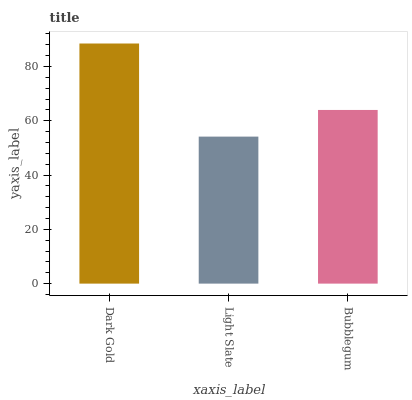Is Light Slate the minimum?
Answer yes or no. Yes. Is Dark Gold the maximum?
Answer yes or no. Yes. Is Bubblegum the minimum?
Answer yes or no. No. Is Bubblegum the maximum?
Answer yes or no. No. Is Bubblegum greater than Light Slate?
Answer yes or no. Yes. Is Light Slate less than Bubblegum?
Answer yes or no. Yes. Is Light Slate greater than Bubblegum?
Answer yes or no. No. Is Bubblegum less than Light Slate?
Answer yes or no. No. Is Bubblegum the high median?
Answer yes or no. Yes. Is Bubblegum the low median?
Answer yes or no. Yes. Is Dark Gold the high median?
Answer yes or no. No. Is Light Slate the low median?
Answer yes or no. No. 